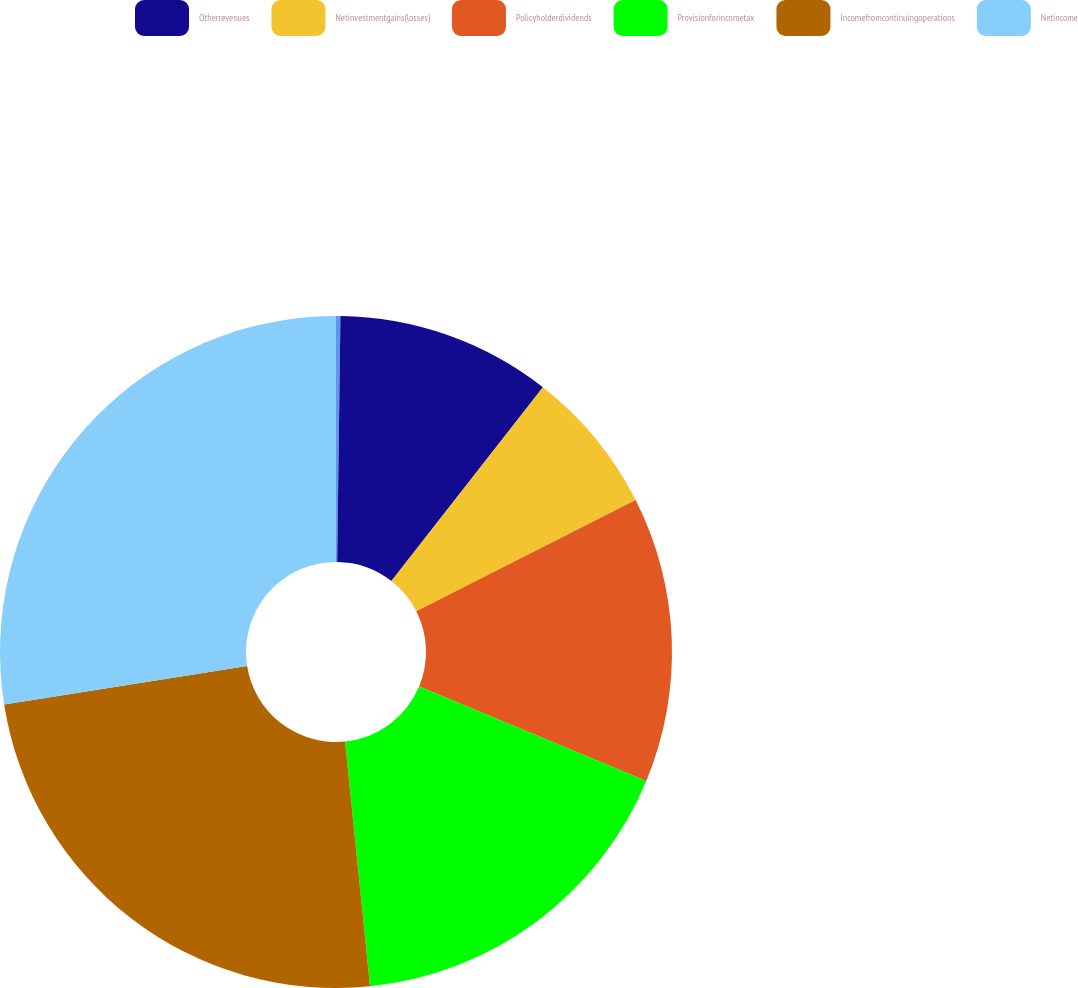Convert chart to OTSL. <chart><loc_0><loc_0><loc_500><loc_500><pie_chart><ecel><fcel>Otherrevenues<fcel>Netinvestmentgains(losses)<fcel>Policyholderdividends<fcel>Provisionforincometax<fcel>Incomefromcontinuingoperations<fcel>Netincome<nl><fcel>0.21%<fcel>10.35%<fcel>6.97%<fcel>13.74%<fcel>17.12%<fcel>24.12%<fcel>27.5%<nl></chart> 